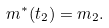<formula> <loc_0><loc_0><loc_500><loc_500>m ^ { * } ( t _ { 2 } ) = m _ { 2 } .</formula> 